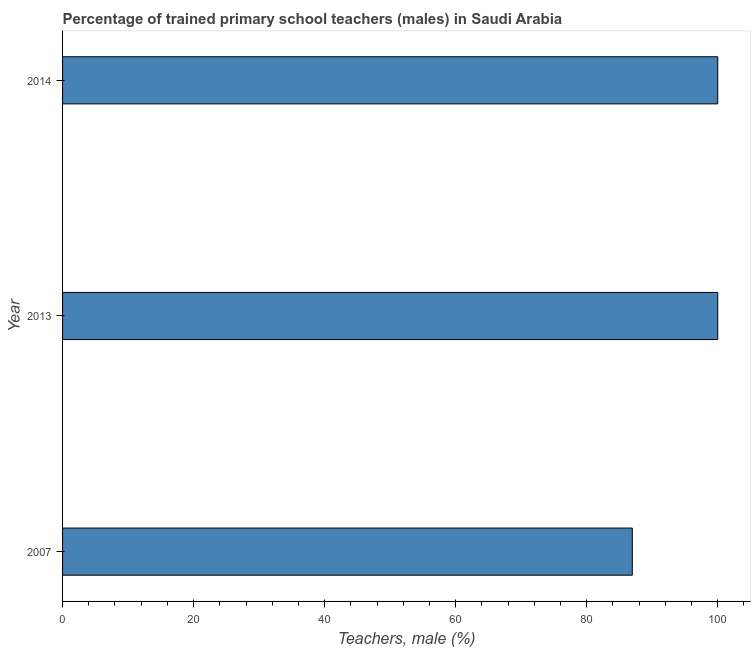Does the graph contain any zero values?
Provide a short and direct response. No. What is the title of the graph?
Offer a very short reply. Percentage of trained primary school teachers (males) in Saudi Arabia. What is the label or title of the X-axis?
Make the answer very short. Teachers, male (%). What is the label or title of the Y-axis?
Offer a terse response. Year. What is the percentage of trained male teachers in 2007?
Keep it short and to the point. 86.96. Across all years, what is the minimum percentage of trained male teachers?
Your response must be concise. 86.96. In which year was the percentage of trained male teachers minimum?
Your answer should be compact. 2007. What is the sum of the percentage of trained male teachers?
Your response must be concise. 286.96. What is the average percentage of trained male teachers per year?
Provide a succinct answer. 95.65. What is the median percentage of trained male teachers?
Make the answer very short. 100. What is the ratio of the percentage of trained male teachers in 2007 to that in 2014?
Provide a succinct answer. 0.87. Is the percentage of trained male teachers in 2013 less than that in 2014?
Your answer should be compact. No. Is the sum of the percentage of trained male teachers in 2007 and 2013 greater than the maximum percentage of trained male teachers across all years?
Keep it short and to the point. Yes. What is the difference between the highest and the lowest percentage of trained male teachers?
Provide a succinct answer. 13.04. Are the values on the major ticks of X-axis written in scientific E-notation?
Your answer should be very brief. No. What is the Teachers, male (%) in 2007?
Offer a terse response. 86.96. What is the Teachers, male (%) of 2014?
Make the answer very short. 100. What is the difference between the Teachers, male (%) in 2007 and 2013?
Provide a short and direct response. -13.04. What is the difference between the Teachers, male (%) in 2007 and 2014?
Give a very brief answer. -13.04. What is the difference between the Teachers, male (%) in 2013 and 2014?
Provide a succinct answer. 0. What is the ratio of the Teachers, male (%) in 2007 to that in 2013?
Your response must be concise. 0.87. What is the ratio of the Teachers, male (%) in 2007 to that in 2014?
Your response must be concise. 0.87. 